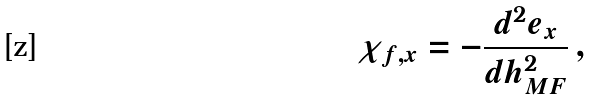Convert formula to latex. <formula><loc_0><loc_0><loc_500><loc_500>\chi _ { f , x } = - \frac { d ^ { 2 } e _ { x } } { d h _ { M F } ^ { 2 } } \, ,</formula> 